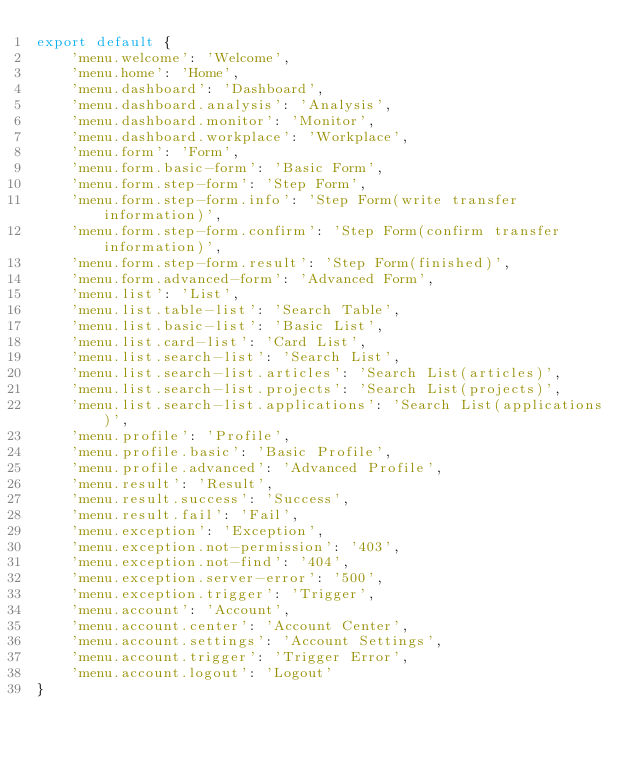Convert code to text. <code><loc_0><loc_0><loc_500><loc_500><_JavaScript_>export default {
    'menu.welcome': 'Welcome',
    'menu.home': 'Home',
    'menu.dashboard': 'Dashboard',
    'menu.dashboard.analysis': 'Analysis',
    'menu.dashboard.monitor': 'Monitor',
    'menu.dashboard.workplace': 'Workplace',
    'menu.form': 'Form',
    'menu.form.basic-form': 'Basic Form',
    'menu.form.step-form': 'Step Form',
    'menu.form.step-form.info': 'Step Form(write transfer information)',
    'menu.form.step-form.confirm': 'Step Form(confirm transfer information)',
    'menu.form.step-form.result': 'Step Form(finished)',
    'menu.form.advanced-form': 'Advanced Form',
    'menu.list': 'List',
    'menu.list.table-list': 'Search Table',
    'menu.list.basic-list': 'Basic List',
    'menu.list.card-list': 'Card List',
    'menu.list.search-list': 'Search List',
    'menu.list.search-list.articles': 'Search List(articles)',
    'menu.list.search-list.projects': 'Search List(projects)',
    'menu.list.search-list.applications': 'Search List(applications)',
    'menu.profile': 'Profile',
    'menu.profile.basic': 'Basic Profile',
    'menu.profile.advanced': 'Advanced Profile',
    'menu.result': 'Result',
    'menu.result.success': 'Success',
    'menu.result.fail': 'Fail',
    'menu.exception': 'Exception',
    'menu.exception.not-permission': '403',
    'menu.exception.not-find': '404',
    'menu.exception.server-error': '500',
    'menu.exception.trigger': 'Trigger',
    'menu.account': 'Account',
    'menu.account.center': 'Account Center',
    'menu.account.settings': 'Account Settings',
    'menu.account.trigger': 'Trigger Error',
    'menu.account.logout': 'Logout'
}
</code> 